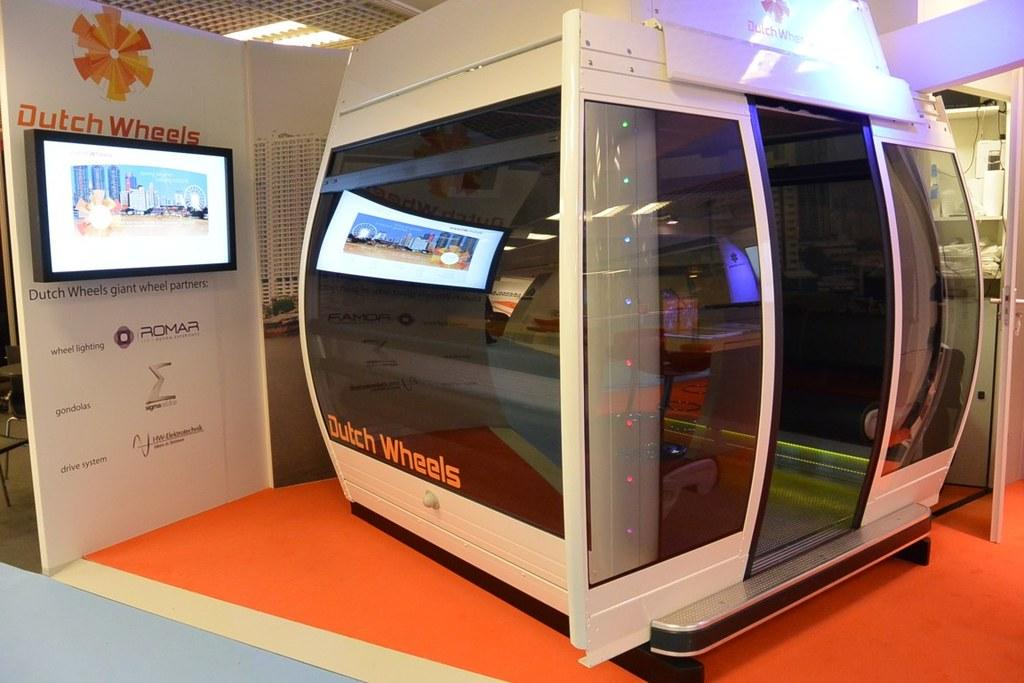<image>
Describe the image concisely. Dutch Wheels has set up a display at a convention. 